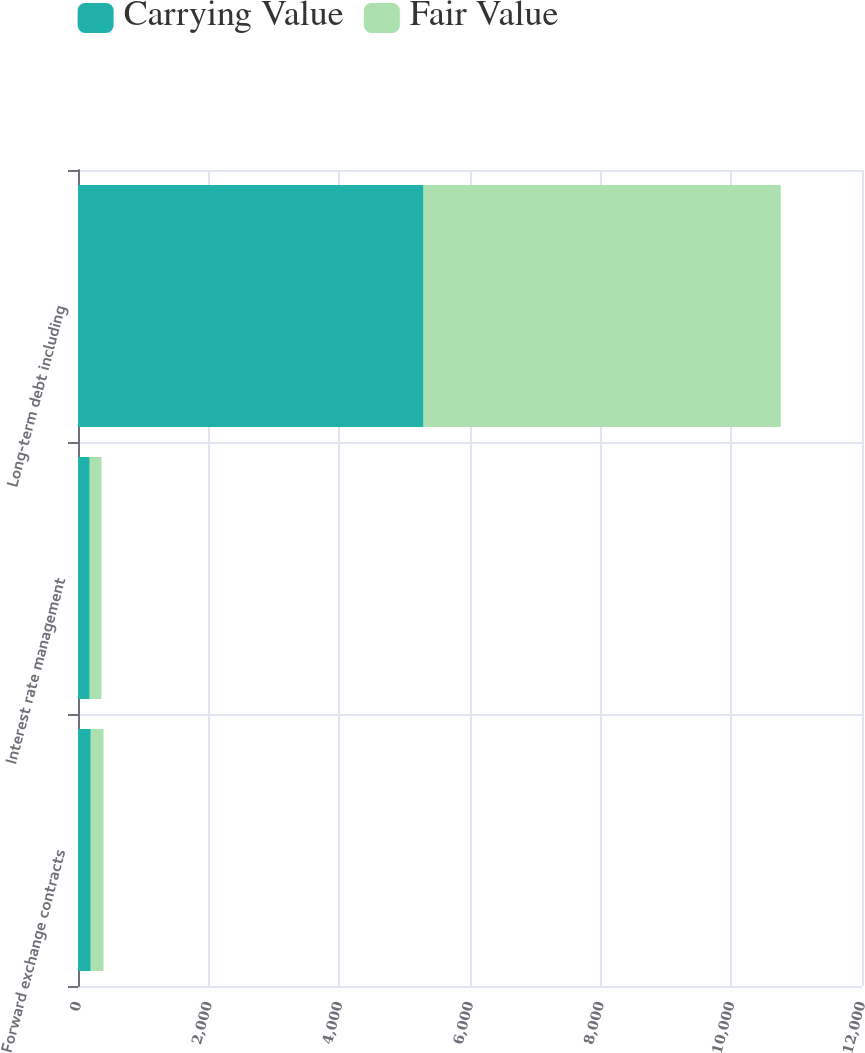Convert chart. <chart><loc_0><loc_0><loc_500><loc_500><stacked_bar_chart><ecel><fcel>Forward exchange contracts<fcel>Interest rate management<fcel>Long-term debt including<nl><fcel>Carrying Value<fcel>195.4<fcel>179.9<fcel>5289.4<nl><fcel>Fair Value<fcel>195.4<fcel>179.9<fcel>5467.2<nl></chart> 